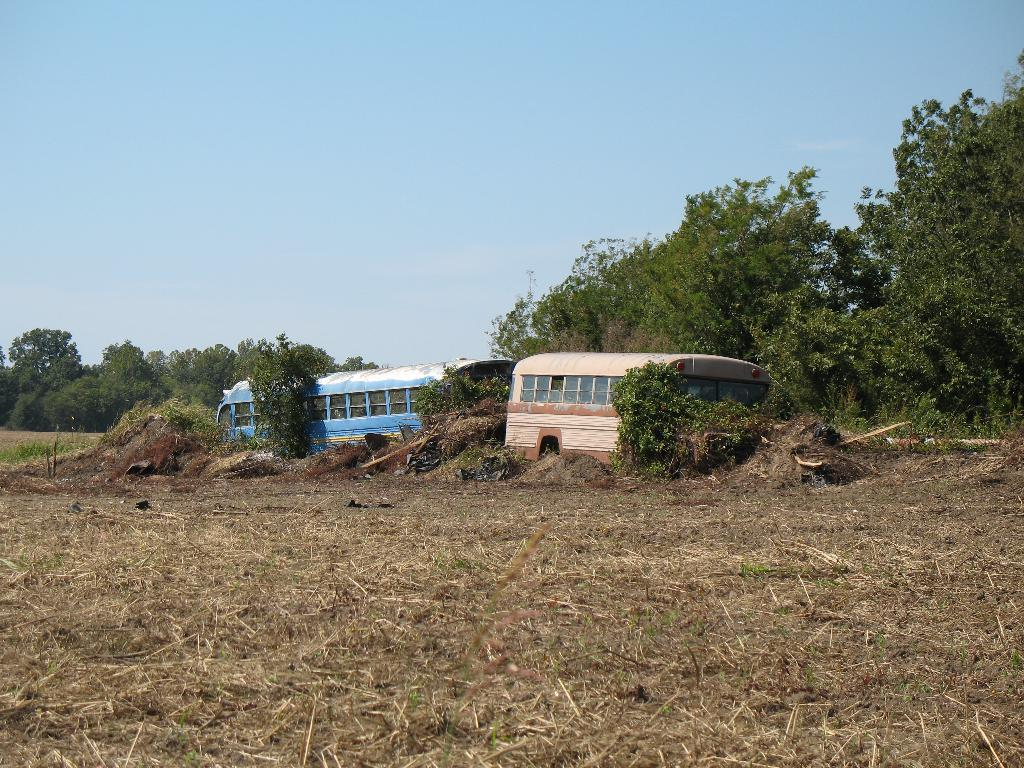How many buses can be seen in the image? There are two buses in the image. Where are the buses located? The buses are parked in an open area. What are the colors of the buses? The buses are of different colors. What can be seen in the background of the image? There are trees and the sky in the background of the image. How many apples are on top of the buses in the image? There are no apples present in the image. What type of hydrant is visible near the buses in the image? There is no hydrant visible in the image. 